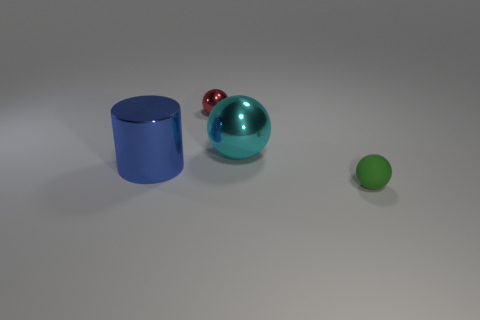The other object that is the same size as the green rubber object is what shape?
Offer a very short reply. Sphere. Is there a small green rubber ball that is behind the big metal object right of the small red metal object?
Your response must be concise. No. What is the color of the rubber thing that is the same shape as the tiny red metal object?
Your answer should be compact. Green. There is a large shiny thing to the left of the cyan metallic sphere; is its color the same as the large sphere?
Offer a terse response. No. How many things are things that are right of the blue thing or blue objects?
Ensure brevity in your answer.  4. What material is the large thing that is on the left side of the tiny object that is behind the tiny sphere in front of the red metal ball made of?
Give a very brief answer. Metal. Are there more green rubber things behind the tiny green ball than blue metal things behind the large ball?
Offer a terse response. No. What number of cubes are gray objects or big things?
Offer a terse response. 0. What number of cyan shiny spheres are left of the tiny object that is behind the tiny ball in front of the red object?
Give a very brief answer. 0. Are there more tiny gray metal spheres than small red objects?
Offer a very short reply. No. 